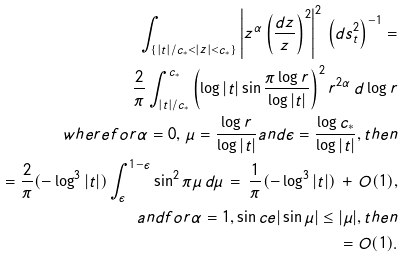Convert formula to latex. <formula><loc_0><loc_0><loc_500><loc_500>\int _ { \{ | t | / c _ { * } < | z | < c _ { * } \} } \left | z ^ { \alpha } \left ( \frac { d z } { z } \right ) ^ { 2 } \right | ^ { 2 } \, \left ( d s ^ { 2 } _ { t } \right ) ^ { - 1 } = \\ \frac { 2 } { \pi } \int ^ { c _ { * } } _ { | t | / c _ { * } } \left ( \log | t | \sin \frac { \pi \log r } { \log | t | } \right ) ^ { 2 } r ^ { 2 \alpha } \, d \log r \\ w h e r e f o r \alpha = 0 , \, \mu = \frac { \log r } { \log | t | } a n d \epsilon = \frac { \log c _ { * } } { \log | t | } , t h e n \\ = \frac { 2 } { \pi } ( - \log ^ { 3 } | t | ) \int ^ { 1 - \epsilon } _ { \epsilon } \sin ^ { 2 } \pi \mu \, d \mu \, = \, \frac { 1 } { \pi } ( - \log ^ { 3 } | t | ) \, + \, O ( 1 ) , \\ a n d f o r \alpha = 1 , \sin c e | \sin \mu | \leq | \mu | , t h e n \\ = O ( 1 ) .</formula> 